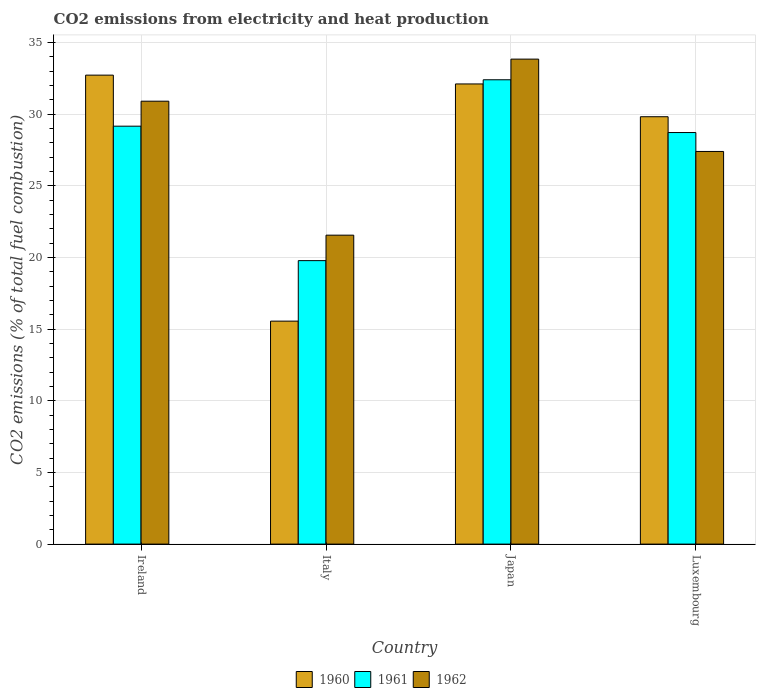How many different coloured bars are there?
Provide a succinct answer. 3. How many groups of bars are there?
Your answer should be compact. 4. What is the amount of CO2 emitted in 1962 in Ireland?
Offer a terse response. 30.9. Across all countries, what is the maximum amount of CO2 emitted in 1961?
Provide a succinct answer. 32.39. Across all countries, what is the minimum amount of CO2 emitted in 1962?
Offer a very short reply. 21.55. In which country was the amount of CO2 emitted in 1962 minimum?
Give a very brief answer. Italy. What is the total amount of CO2 emitted in 1962 in the graph?
Your answer should be very brief. 113.67. What is the difference between the amount of CO2 emitted in 1962 in Ireland and that in Luxembourg?
Your answer should be compact. 3.51. What is the difference between the amount of CO2 emitted in 1961 in Italy and the amount of CO2 emitted in 1962 in Japan?
Your answer should be very brief. -14.06. What is the average amount of CO2 emitted in 1961 per country?
Your answer should be compact. 27.51. What is the difference between the amount of CO2 emitted of/in 1960 and amount of CO2 emitted of/in 1962 in Ireland?
Make the answer very short. 1.82. In how many countries, is the amount of CO2 emitted in 1962 greater than 34 %?
Your answer should be compact. 0. What is the ratio of the amount of CO2 emitted in 1962 in Italy to that in Japan?
Ensure brevity in your answer.  0.64. Is the amount of CO2 emitted in 1960 in Ireland less than that in Japan?
Ensure brevity in your answer.  No. What is the difference between the highest and the second highest amount of CO2 emitted in 1960?
Your answer should be very brief. 0.61. What is the difference between the highest and the lowest amount of CO2 emitted in 1961?
Ensure brevity in your answer.  12.62. In how many countries, is the amount of CO2 emitted in 1962 greater than the average amount of CO2 emitted in 1962 taken over all countries?
Offer a very short reply. 2. Is the sum of the amount of CO2 emitted in 1961 in Ireland and Japan greater than the maximum amount of CO2 emitted in 1960 across all countries?
Offer a very short reply. Yes. What does the 1st bar from the right in Ireland represents?
Offer a very short reply. 1962. Is it the case that in every country, the sum of the amount of CO2 emitted in 1961 and amount of CO2 emitted in 1960 is greater than the amount of CO2 emitted in 1962?
Make the answer very short. Yes. How many bars are there?
Keep it short and to the point. 12. Are all the bars in the graph horizontal?
Offer a very short reply. No. What is the difference between two consecutive major ticks on the Y-axis?
Your answer should be very brief. 5. Are the values on the major ticks of Y-axis written in scientific E-notation?
Offer a terse response. No. Does the graph contain grids?
Offer a terse response. Yes. Where does the legend appear in the graph?
Ensure brevity in your answer.  Bottom center. How many legend labels are there?
Your answer should be compact. 3. What is the title of the graph?
Your answer should be compact. CO2 emissions from electricity and heat production. Does "2004" appear as one of the legend labels in the graph?
Your answer should be very brief. No. What is the label or title of the X-axis?
Provide a short and direct response. Country. What is the label or title of the Y-axis?
Give a very brief answer. CO2 emissions (% of total fuel combustion). What is the CO2 emissions (% of total fuel combustion) in 1960 in Ireland?
Offer a very short reply. 32.72. What is the CO2 emissions (% of total fuel combustion) in 1961 in Ireland?
Keep it short and to the point. 29.15. What is the CO2 emissions (% of total fuel combustion) of 1962 in Ireland?
Keep it short and to the point. 30.9. What is the CO2 emissions (% of total fuel combustion) of 1960 in Italy?
Your answer should be compact. 15.55. What is the CO2 emissions (% of total fuel combustion) of 1961 in Italy?
Ensure brevity in your answer.  19.78. What is the CO2 emissions (% of total fuel combustion) of 1962 in Italy?
Provide a succinct answer. 21.55. What is the CO2 emissions (% of total fuel combustion) in 1960 in Japan?
Make the answer very short. 32.1. What is the CO2 emissions (% of total fuel combustion) in 1961 in Japan?
Your answer should be very brief. 32.39. What is the CO2 emissions (% of total fuel combustion) of 1962 in Japan?
Offer a terse response. 33.83. What is the CO2 emissions (% of total fuel combustion) in 1960 in Luxembourg?
Provide a succinct answer. 29.81. What is the CO2 emissions (% of total fuel combustion) of 1961 in Luxembourg?
Provide a short and direct response. 28.71. What is the CO2 emissions (% of total fuel combustion) in 1962 in Luxembourg?
Give a very brief answer. 27.39. Across all countries, what is the maximum CO2 emissions (% of total fuel combustion) in 1960?
Offer a terse response. 32.72. Across all countries, what is the maximum CO2 emissions (% of total fuel combustion) of 1961?
Give a very brief answer. 32.39. Across all countries, what is the maximum CO2 emissions (% of total fuel combustion) of 1962?
Make the answer very short. 33.83. Across all countries, what is the minimum CO2 emissions (% of total fuel combustion) in 1960?
Keep it short and to the point. 15.55. Across all countries, what is the minimum CO2 emissions (% of total fuel combustion) in 1961?
Make the answer very short. 19.78. Across all countries, what is the minimum CO2 emissions (% of total fuel combustion) of 1962?
Ensure brevity in your answer.  21.55. What is the total CO2 emissions (% of total fuel combustion) in 1960 in the graph?
Your response must be concise. 110.19. What is the total CO2 emissions (% of total fuel combustion) of 1961 in the graph?
Offer a terse response. 110.03. What is the total CO2 emissions (% of total fuel combustion) in 1962 in the graph?
Your response must be concise. 113.67. What is the difference between the CO2 emissions (% of total fuel combustion) of 1960 in Ireland and that in Italy?
Your answer should be compact. 17.16. What is the difference between the CO2 emissions (% of total fuel combustion) in 1961 in Ireland and that in Italy?
Ensure brevity in your answer.  9.38. What is the difference between the CO2 emissions (% of total fuel combustion) of 1962 in Ireland and that in Italy?
Your answer should be very brief. 9.35. What is the difference between the CO2 emissions (% of total fuel combustion) in 1960 in Ireland and that in Japan?
Offer a very short reply. 0.61. What is the difference between the CO2 emissions (% of total fuel combustion) of 1961 in Ireland and that in Japan?
Make the answer very short. -3.24. What is the difference between the CO2 emissions (% of total fuel combustion) in 1962 in Ireland and that in Japan?
Provide a short and direct response. -2.94. What is the difference between the CO2 emissions (% of total fuel combustion) of 1960 in Ireland and that in Luxembourg?
Offer a very short reply. 2.9. What is the difference between the CO2 emissions (% of total fuel combustion) in 1961 in Ireland and that in Luxembourg?
Offer a terse response. 0.44. What is the difference between the CO2 emissions (% of total fuel combustion) in 1962 in Ireland and that in Luxembourg?
Keep it short and to the point. 3.51. What is the difference between the CO2 emissions (% of total fuel combustion) of 1960 in Italy and that in Japan?
Your answer should be very brief. -16.55. What is the difference between the CO2 emissions (% of total fuel combustion) of 1961 in Italy and that in Japan?
Make the answer very short. -12.62. What is the difference between the CO2 emissions (% of total fuel combustion) of 1962 in Italy and that in Japan?
Your response must be concise. -12.28. What is the difference between the CO2 emissions (% of total fuel combustion) in 1960 in Italy and that in Luxembourg?
Offer a very short reply. -14.26. What is the difference between the CO2 emissions (% of total fuel combustion) in 1961 in Italy and that in Luxembourg?
Keep it short and to the point. -8.93. What is the difference between the CO2 emissions (% of total fuel combustion) of 1962 in Italy and that in Luxembourg?
Make the answer very short. -5.84. What is the difference between the CO2 emissions (% of total fuel combustion) of 1960 in Japan and that in Luxembourg?
Provide a short and direct response. 2.29. What is the difference between the CO2 emissions (% of total fuel combustion) in 1961 in Japan and that in Luxembourg?
Keep it short and to the point. 3.68. What is the difference between the CO2 emissions (% of total fuel combustion) of 1962 in Japan and that in Luxembourg?
Offer a very short reply. 6.44. What is the difference between the CO2 emissions (% of total fuel combustion) of 1960 in Ireland and the CO2 emissions (% of total fuel combustion) of 1961 in Italy?
Give a very brief answer. 12.94. What is the difference between the CO2 emissions (% of total fuel combustion) in 1960 in Ireland and the CO2 emissions (% of total fuel combustion) in 1962 in Italy?
Offer a very short reply. 11.16. What is the difference between the CO2 emissions (% of total fuel combustion) in 1961 in Ireland and the CO2 emissions (% of total fuel combustion) in 1962 in Italy?
Your answer should be very brief. 7.6. What is the difference between the CO2 emissions (% of total fuel combustion) in 1960 in Ireland and the CO2 emissions (% of total fuel combustion) in 1961 in Japan?
Offer a very short reply. 0.32. What is the difference between the CO2 emissions (% of total fuel combustion) of 1960 in Ireland and the CO2 emissions (% of total fuel combustion) of 1962 in Japan?
Your answer should be compact. -1.12. What is the difference between the CO2 emissions (% of total fuel combustion) of 1961 in Ireland and the CO2 emissions (% of total fuel combustion) of 1962 in Japan?
Your answer should be very brief. -4.68. What is the difference between the CO2 emissions (% of total fuel combustion) in 1960 in Ireland and the CO2 emissions (% of total fuel combustion) in 1961 in Luxembourg?
Offer a terse response. 4.01. What is the difference between the CO2 emissions (% of total fuel combustion) of 1960 in Ireland and the CO2 emissions (% of total fuel combustion) of 1962 in Luxembourg?
Your response must be concise. 5.33. What is the difference between the CO2 emissions (% of total fuel combustion) in 1961 in Ireland and the CO2 emissions (% of total fuel combustion) in 1962 in Luxembourg?
Your answer should be very brief. 1.76. What is the difference between the CO2 emissions (% of total fuel combustion) of 1960 in Italy and the CO2 emissions (% of total fuel combustion) of 1961 in Japan?
Your answer should be compact. -16.84. What is the difference between the CO2 emissions (% of total fuel combustion) in 1960 in Italy and the CO2 emissions (% of total fuel combustion) in 1962 in Japan?
Your answer should be compact. -18.28. What is the difference between the CO2 emissions (% of total fuel combustion) of 1961 in Italy and the CO2 emissions (% of total fuel combustion) of 1962 in Japan?
Provide a succinct answer. -14.06. What is the difference between the CO2 emissions (% of total fuel combustion) in 1960 in Italy and the CO2 emissions (% of total fuel combustion) in 1961 in Luxembourg?
Keep it short and to the point. -13.16. What is the difference between the CO2 emissions (% of total fuel combustion) in 1960 in Italy and the CO2 emissions (% of total fuel combustion) in 1962 in Luxembourg?
Offer a very short reply. -11.84. What is the difference between the CO2 emissions (% of total fuel combustion) in 1961 in Italy and the CO2 emissions (% of total fuel combustion) in 1962 in Luxembourg?
Your answer should be very brief. -7.62. What is the difference between the CO2 emissions (% of total fuel combustion) of 1960 in Japan and the CO2 emissions (% of total fuel combustion) of 1961 in Luxembourg?
Provide a succinct answer. 3.39. What is the difference between the CO2 emissions (% of total fuel combustion) in 1960 in Japan and the CO2 emissions (% of total fuel combustion) in 1962 in Luxembourg?
Offer a very short reply. 4.71. What is the difference between the CO2 emissions (% of total fuel combustion) of 1961 in Japan and the CO2 emissions (% of total fuel combustion) of 1962 in Luxembourg?
Ensure brevity in your answer.  5. What is the average CO2 emissions (% of total fuel combustion) in 1960 per country?
Your response must be concise. 27.55. What is the average CO2 emissions (% of total fuel combustion) in 1961 per country?
Give a very brief answer. 27.51. What is the average CO2 emissions (% of total fuel combustion) in 1962 per country?
Your answer should be compact. 28.42. What is the difference between the CO2 emissions (% of total fuel combustion) in 1960 and CO2 emissions (% of total fuel combustion) in 1961 in Ireland?
Give a very brief answer. 3.56. What is the difference between the CO2 emissions (% of total fuel combustion) of 1960 and CO2 emissions (% of total fuel combustion) of 1962 in Ireland?
Your answer should be very brief. 1.82. What is the difference between the CO2 emissions (% of total fuel combustion) of 1961 and CO2 emissions (% of total fuel combustion) of 1962 in Ireland?
Make the answer very short. -1.74. What is the difference between the CO2 emissions (% of total fuel combustion) in 1960 and CO2 emissions (% of total fuel combustion) in 1961 in Italy?
Offer a terse response. -4.22. What is the difference between the CO2 emissions (% of total fuel combustion) of 1960 and CO2 emissions (% of total fuel combustion) of 1962 in Italy?
Give a very brief answer. -6. What is the difference between the CO2 emissions (% of total fuel combustion) in 1961 and CO2 emissions (% of total fuel combustion) in 1962 in Italy?
Provide a short and direct response. -1.78. What is the difference between the CO2 emissions (% of total fuel combustion) of 1960 and CO2 emissions (% of total fuel combustion) of 1961 in Japan?
Your response must be concise. -0.29. What is the difference between the CO2 emissions (% of total fuel combustion) in 1960 and CO2 emissions (% of total fuel combustion) in 1962 in Japan?
Your response must be concise. -1.73. What is the difference between the CO2 emissions (% of total fuel combustion) of 1961 and CO2 emissions (% of total fuel combustion) of 1962 in Japan?
Provide a succinct answer. -1.44. What is the difference between the CO2 emissions (% of total fuel combustion) of 1960 and CO2 emissions (% of total fuel combustion) of 1961 in Luxembourg?
Keep it short and to the point. 1.1. What is the difference between the CO2 emissions (% of total fuel combustion) in 1960 and CO2 emissions (% of total fuel combustion) in 1962 in Luxembourg?
Offer a very short reply. 2.42. What is the difference between the CO2 emissions (% of total fuel combustion) in 1961 and CO2 emissions (% of total fuel combustion) in 1962 in Luxembourg?
Give a very brief answer. 1.32. What is the ratio of the CO2 emissions (% of total fuel combustion) of 1960 in Ireland to that in Italy?
Keep it short and to the point. 2.1. What is the ratio of the CO2 emissions (% of total fuel combustion) of 1961 in Ireland to that in Italy?
Give a very brief answer. 1.47. What is the ratio of the CO2 emissions (% of total fuel combustion) in 1962 in Ireland to that in Italy?
Provide a short and direct response. 1.43. What is the ratio of the CO2 emissions (% of total fuel combustion) in 1960 in Ireland to that in Japan?
Provide a succinct answer. 1.02. What is the ratio of the CO2 emissions (% of total fuel combustion) in 1962 in Ireland to that in Japan?
Give a very brief answer. 0.91. What is the ratio of the CO2 emissions (% of total fuel combustion) of 1960 in Ireland to that in Luxembourg?
Your response must be concise. 1.1. What is the ratio of the CO2 emissions (% of total fuel combustion) in 1961 in Ireland to that in Luxembourg?
Ensure brevity in your answer.  1.02. What is the ratio of the CO2 emissions (% of total fuel combustion) in 1962 in Ireland to that in Luxembourg?
Ensure brevity in your answer.  1.13. What is the ratio of the CO2 emissions (% of total fuel combustion) of 1960 in Italy to that in Japan?
Your response must be concise. 0.48. What is the ratio of the CO2 emissions (% of total fuel combustion) of 1961 in Italy to that in Japan?
Keep it short and to the point. 0.61. What is the ratio of the CO2 emissions (% of total fuel combustion) in 1962 in Italy to that in Japan?
Give a very brief answer. 0.64. What is the ratio of the CO2 emissions (% of total fuel combustion) in 1960 in Italy to that in Luxembourg?
Provide a short and direct response. 0.52. What is the ratio of the CO2 emissions (% of total fuel combustion) in 1961 in Italy to that in Luxembourg?
Make the answer very short. 0.69. What is the ratio of the CO2 emissions (% of total fuel combustion) in 1962 in Italy to that in Luxembourg?
Your answer should be compact. 0.79. What is the ratio of the CO2 emissions (% of total fuel combustion) of 1960 in Japan to that in Luxembourg?
Keep it short and to the point. 1.08. What is the ratio of the CO2 emissions (% of total fuel combustion) of 1961 in Japan to that in Luxembourg?
Provide a succinct answer. 1.13. What is the ratio of the CO2 emissions (% of total fuel combustion) of 1962 in Japan to that in Luxembourg?
Your answer should be very brief. 1.24. What is the difference between the highest and the second highest CO2 emissions (% of total fuel combustion) of 1960?
Provide a succinct answer. 0.61. What is the difference between the highest and the second highest CO2 emissions (% of total fuel combustion) of 1961?
Offer a very short reply. 3.24. What is the difference between the highest and the second highest CO2 emissions (% of total fuel combustion) in 1962?
Your response must be concise. 2.94. What is the difference between the highest and the lowest CO2 emissions (% of total fuel combustion) in 1960?
Make the answer very short. 17.16. What is the difference between the highest and the lowest CO2 emissions (% of total fuel combustion) in 1961?
Your response must be concise. 12.62. What is the difference between the highest and the lowest CO2 emissions (% of total fuel combustion) of 1962?
Your response must be concise. 12.28. 